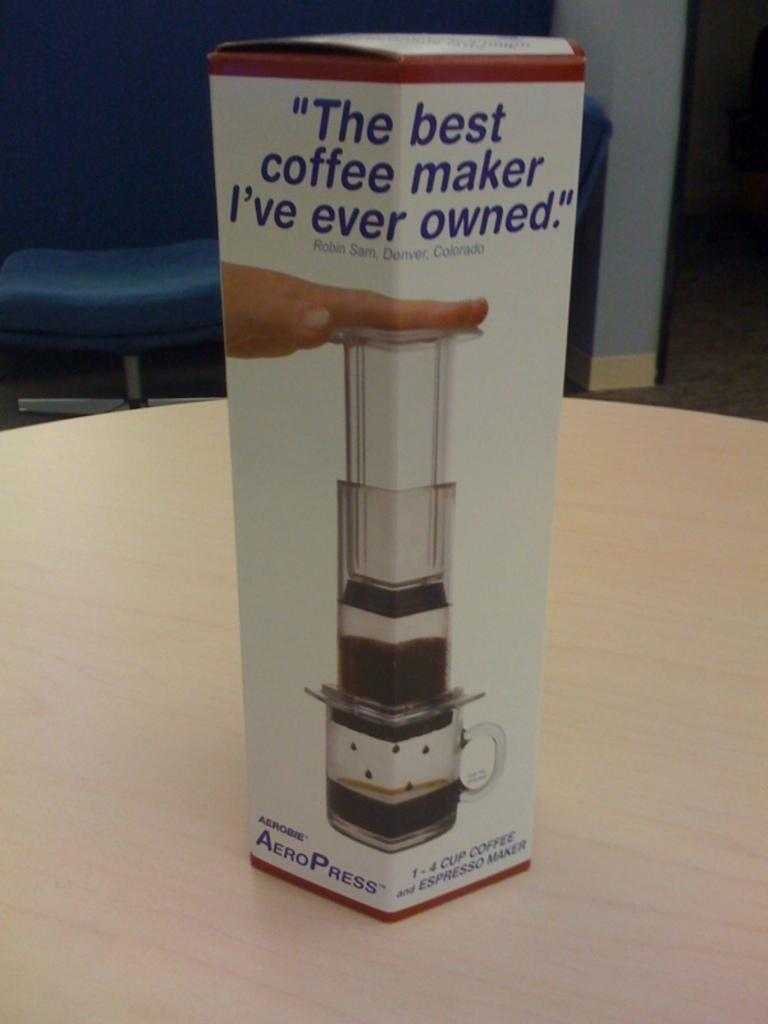What is the main object in the image? There is a box in the image. On what surface is the box placed? The box is placed on a wooden surface. What can be seen on top of the box? There are glass objects on the box. Can you describe the human presence in the image? A human hand is visible in the image. What information is provided on the box? There is text on the box. What can be seen in the background of the image? There is a chair, the floor, and a wall visible in the background of the image. What is the tendency of the box to change its size in the image? The box does not change its size in the image; it remains the same size throughout. 